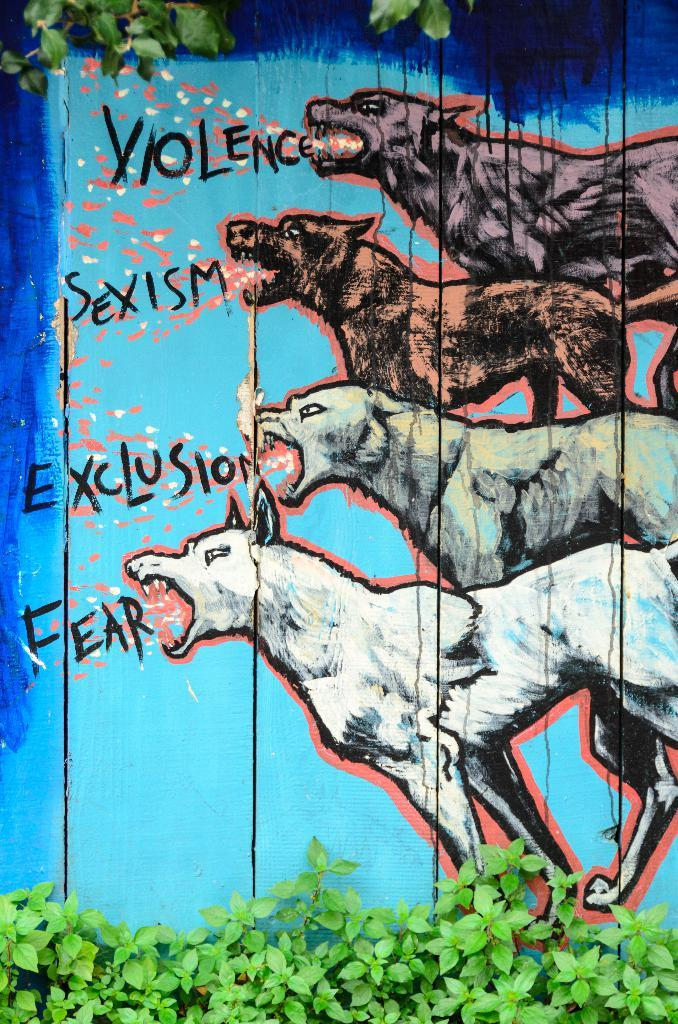What is depicted on the wooden surface in the image? There is a painting of four dogs on a wooden surface. What else can be seen on the wooden surface besides the painting? There is text written on the wooden surface. What type of vegetation is present in the image? There is a tree and many plants in the image. How many trains can be seen passing by the tree in the image? There are no trains present in the image; it features a painting of four dogs, text on a wooden surface, and vegetation. 